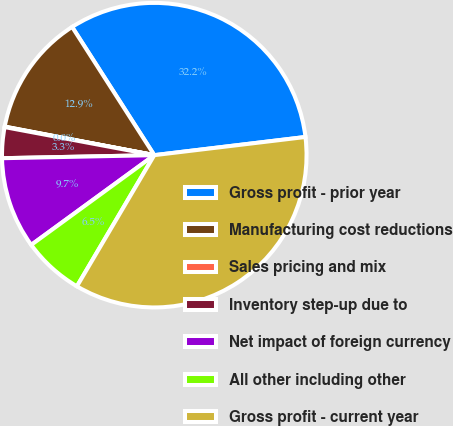<chart> <loc_0><loc_0><loc_500><loc_500><pie_chart><fcel>Gross profit - prior year<fcel>Manufacturing cost reductions<fcel>Sales pricing and mix<fcel>Inventory step-up due to<fcel>Net impact of foreign currency<fcel>All other including other<fcel>Gross profit - current year<nl><fcel>32.17%<fcel>12.93%<fcel>0.05%<fcel>3.27%<fcel>9.71%<fcel>6.49%<fcel>35.39%<nl></chart> 